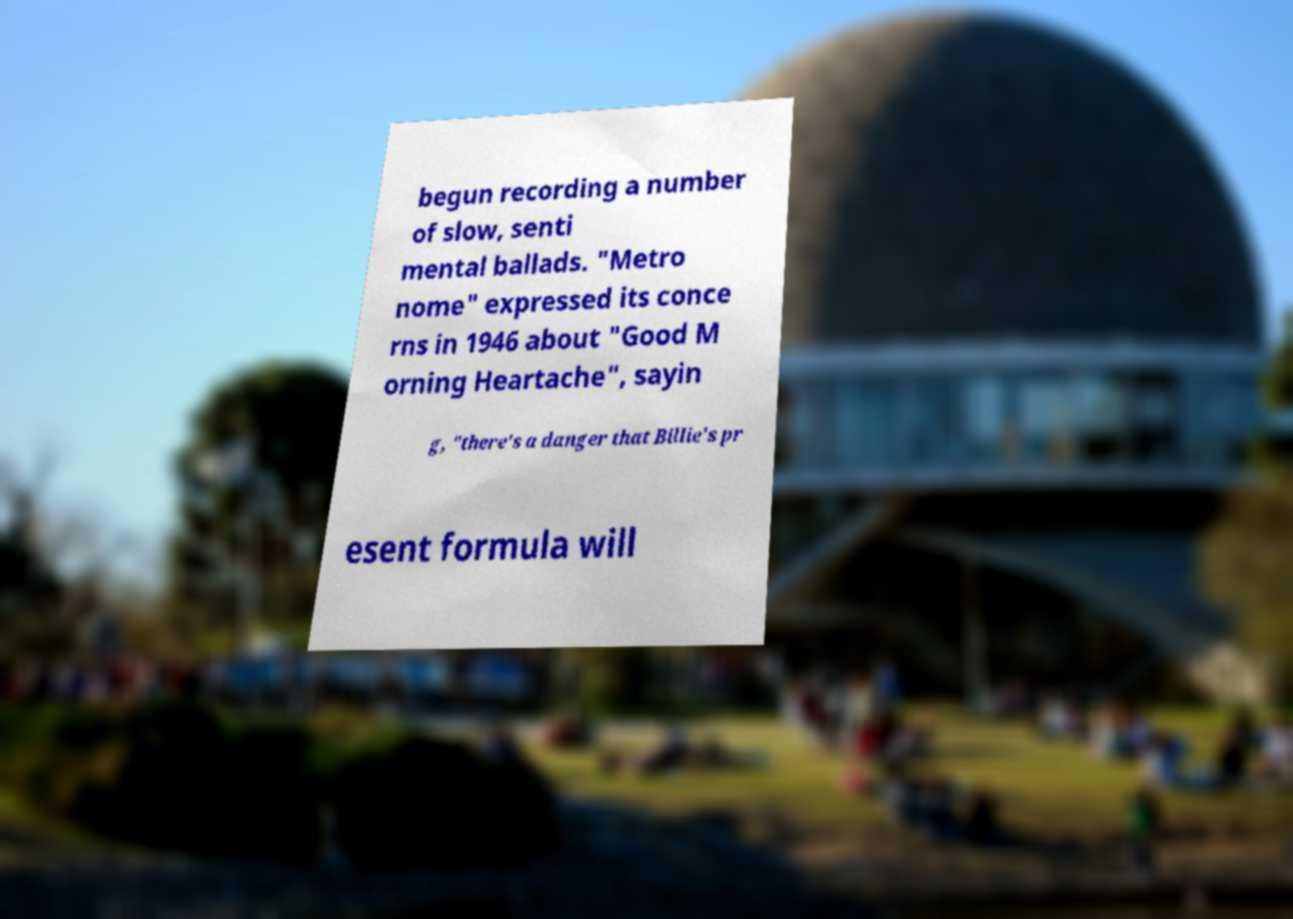For documentation purposes, I need the text within this image transcribed. Could you provide that? begun recording a number of slow, senti mental ballads. "Metro nome" expressed its conce rns in 1946 about "Good M orning Heartache", sayin g, "there's a danger that Billie's pr esent formula will 